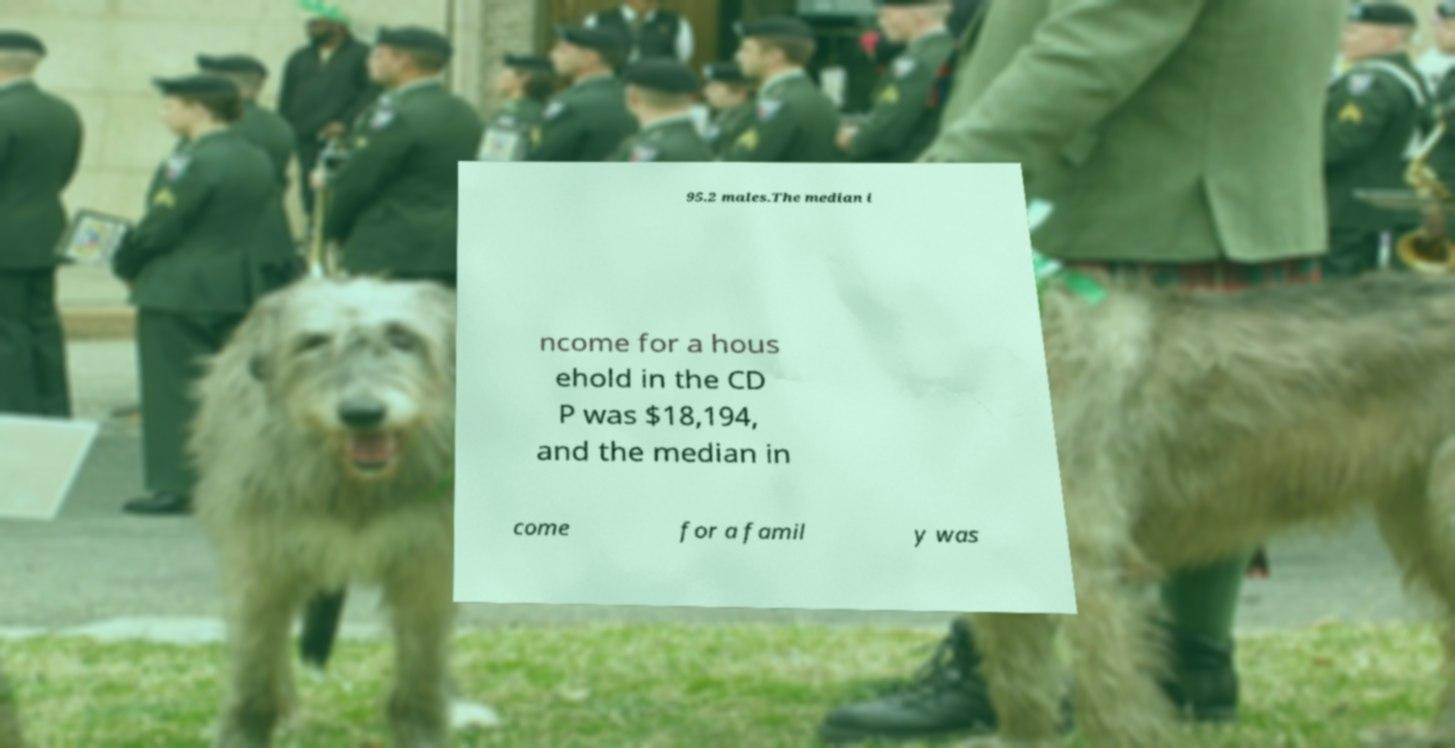For documentation purposes, I need the text within this image transcribed. Could you provide that? 95.2 males.The median i ncome for a hous ehold in the CD P was $18,194, and the median in come for a famil y was 